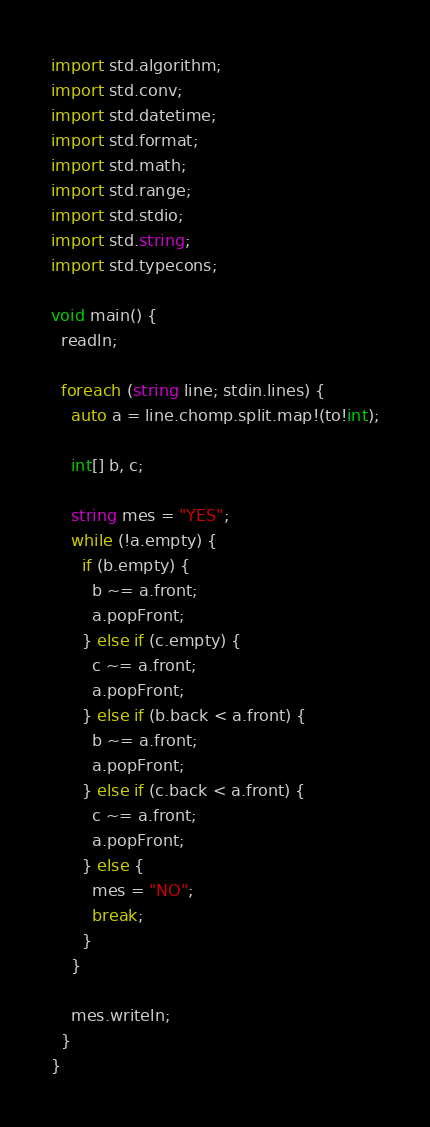<code> <loc_0><loc_0><loc_500><loc_500><_D_>import std.algorithm;
import std.conv;
import std.datetime;
import std.format;
import std.math;
import std.range;
import std.stdio;
import std.string;
import std.typecons;

void main() {
  readln;

  foreach (string line; stdin.lines) {
    auto a = line.chomp.split.map!(to!int);

    int[] b, c;

    string mes = "YES";
    while (!a.empty) {
      if (b.empty) {
        b ~= a.front;
        a.popFront;
      } else if (c.empty) {
        c ~= a.front;
        a.popFront;
      } else if (b.back < a.front) {
        b ~= a.front;
        a.popFront;
      } else if (c.back < a.front) {
        c ~= a.front;
        a.popFront;
      } else {
        mes = "NO";
        break;
      }
    }

    mes.writeln;
  }
}</code> 